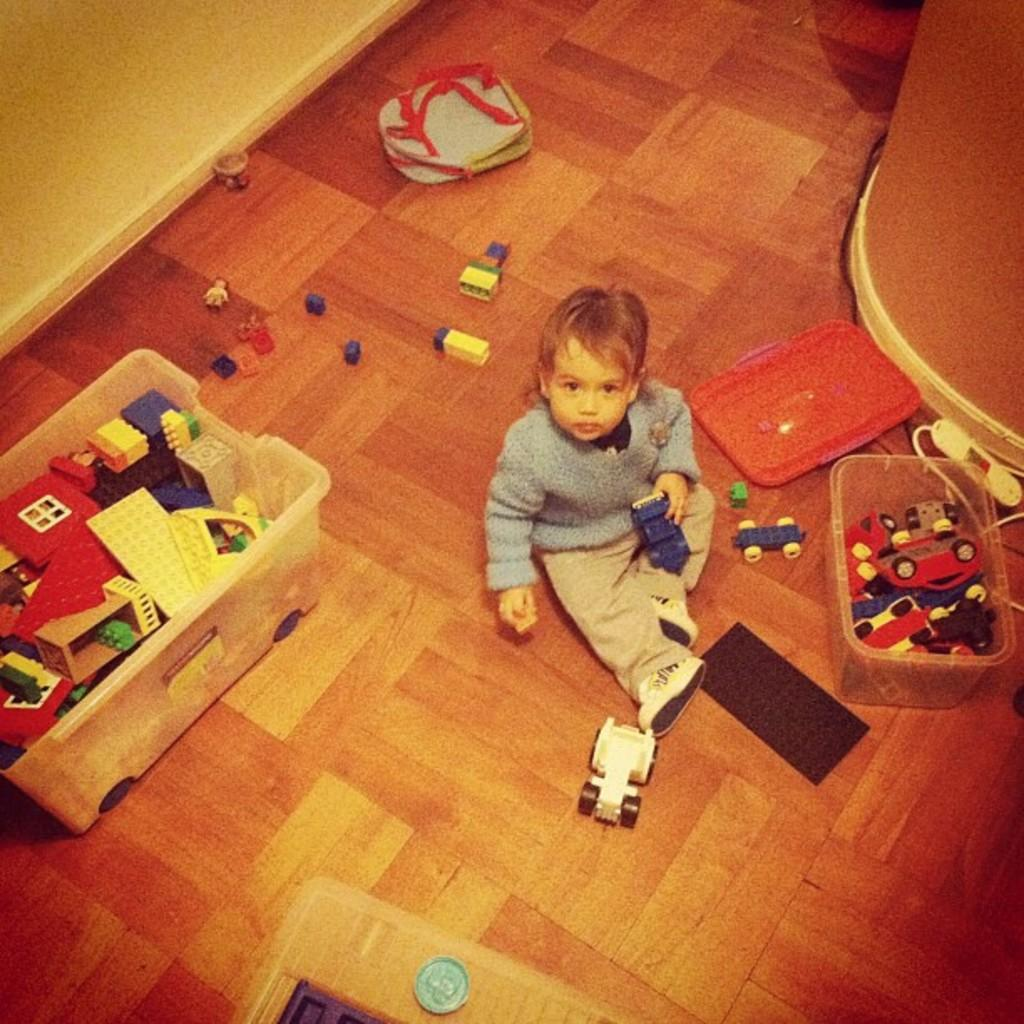What is the person in the image doing? The person is sitting in the image. What is the person holding in the image? The person is holding toys. Where are some of the toys located in the image? Some toys are in a basket, and others are on the floor. What color is the background wall in the image? The background wall is in cream color. What type of flag is visible in the image? There is no flag present in the image. How does the quarter affect the person's actions in the image? There is no mention of a quarter in the image, so it cannot affect the person's actions. 